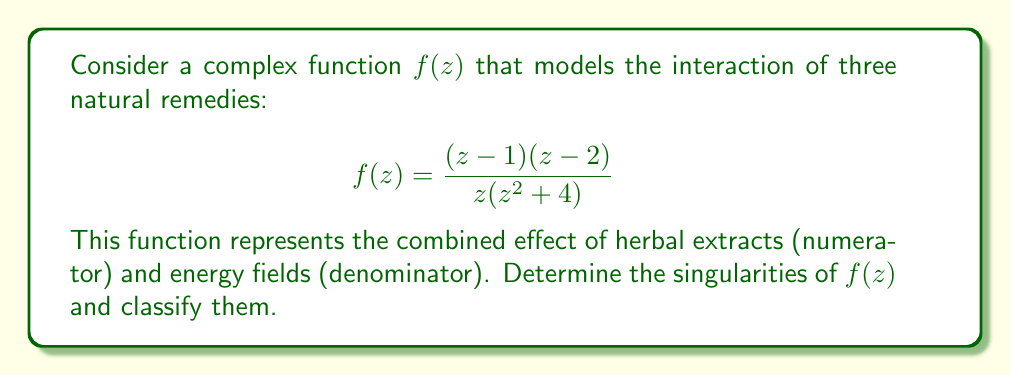Provide a solution to this math problem. To find and classify the singularities of $f(z)$, we need to follow these steps:

1) Identify the points where $f(z)$ is not analytic:
   The function is not analytic when its denominator equals zero.
   
   $z(z^2+4) = 0$
   
   This occurs when $z = 0$ or $z = \pm 2i$

2) Classify each singularity:

   a) For $z = 0$:
      The numerator is finite and non-zero when $z = 0$.
      The denominator has a factor of $z$ to the first power.
      This is a simple pole (order 1 singularity).

   b) For $z = 2i$ and $z = -2i$:
      The numerator is finite and non-zero when $z = \pm 2i$.
      The denominator has a factor of $(z-2i)$ or $(z+2i)$ to the first power.
      These are also simple poles.

3) Check for removable singularities:
   The zeros of the numerator $(z-1)$ and $(z-2)$ do not coincide with any zeros of the denominator.
   Therefore, there are no removable singularities.

4) Check for essential singularities:
   The function has no essential singularities as all singularities are poles.

Therefore, $f(z)$ has three singularities: simple poles at $z = 0$, $z = 2i$, and $z = -2i$.
Answer: Simple poles at $z = 0$, $z = 2i$, and $z = -2i$ 